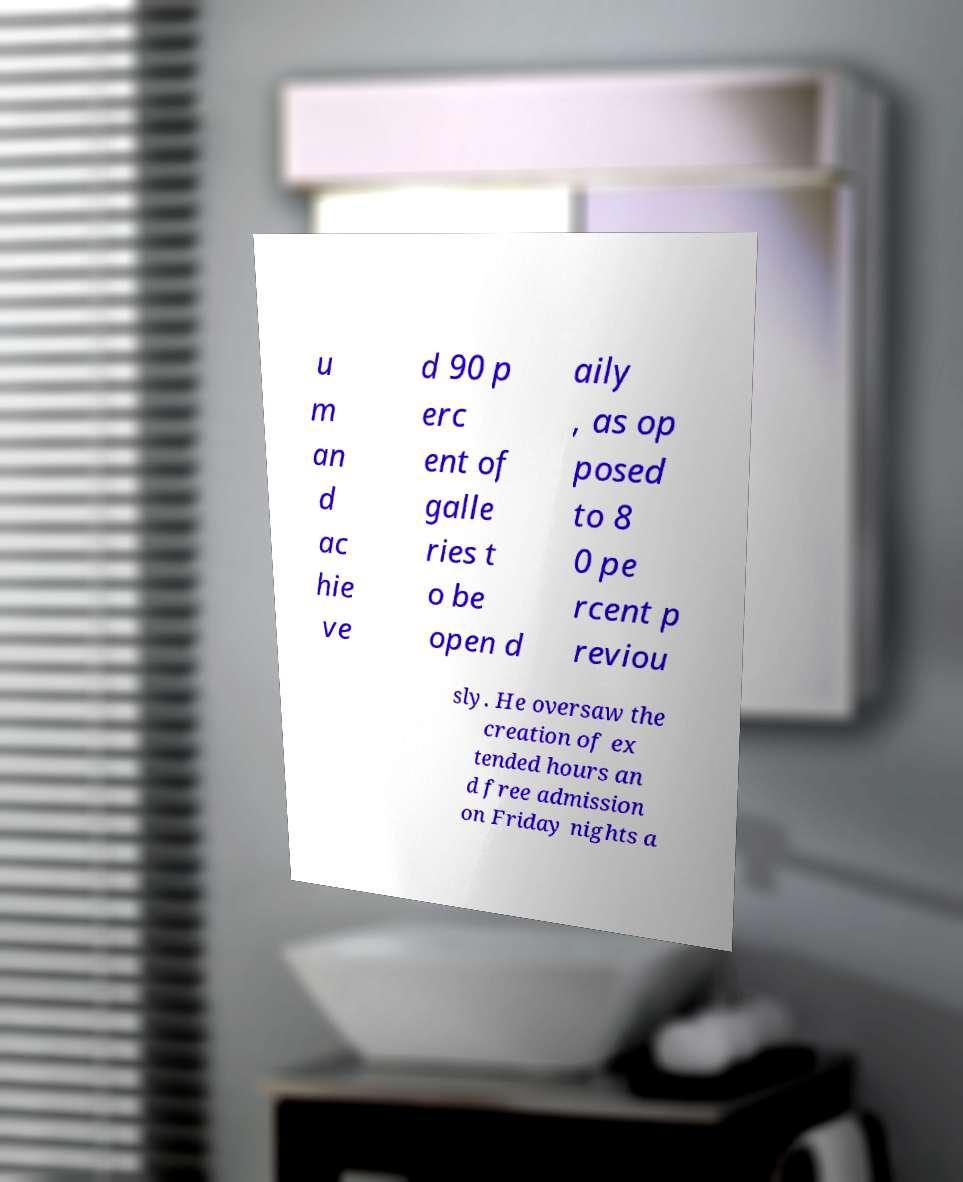Can you accurately transcribe the text from the provided image for me? u m an d ac hie ve d 90 p erc ent of galle ries t o be open d aily , as op posed to 8 0 pe rcent p reviou sly. He oversaw the creation of ex tended hours an d free admission on Friday nights a 